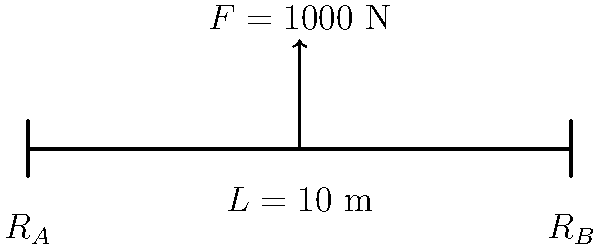In your journey of self-reflection, you come across a metaphor comparing life's challenges to a beam supporting a weight. This reminds you of a simple engineering problem. Consider a beam of length $L = 10$ m supported at both ends, with a downward force $F = 1000$ N applied at its center. Calculate the reaction forces $R_A$ and $R_B$ at the supports, and the maximum bending moment $M_{max}$ in the beam. Let's approach this problem step-by-step, much like how we approach life's challenges with mindfulness:

1) First, we recognize that this is a statically determinate problem. The beam is in equilibrium, so the sum of forces and moments must be zero.

2) Sum of vertical forces:
   $$R_A + R_B - F = 0$$

3) Due to symmetry, we know that $R_A = R_B$. Let's call this value $R$.
   $$2R - 1000 = 0$$
   $$R = 500 \text{ N}$$

4) So, $R_A = R_B = 500 \text{ N}$

5) For the maximum bending moment, it occurs at the center where the force is applied. We can calculate it by considering the moment about the center point:
   $$M_{max} = R_A \cdot \frac{L}{2} = 500 \text{ N} \cdot 5 \text{ m} = 2500 \text{ N⋅m}$$

This problem teaches us that in life, as in engineering, balance is key. The support we receive (reactions) is directly related to the challenges we face (applied force), and our resilience (bending moment) is greatest at the point of maximum stress.
Answer: $R_A = R_B = 500 \text{ N}$, $M_{max} = 2500 \text{ N⋅m}$ 